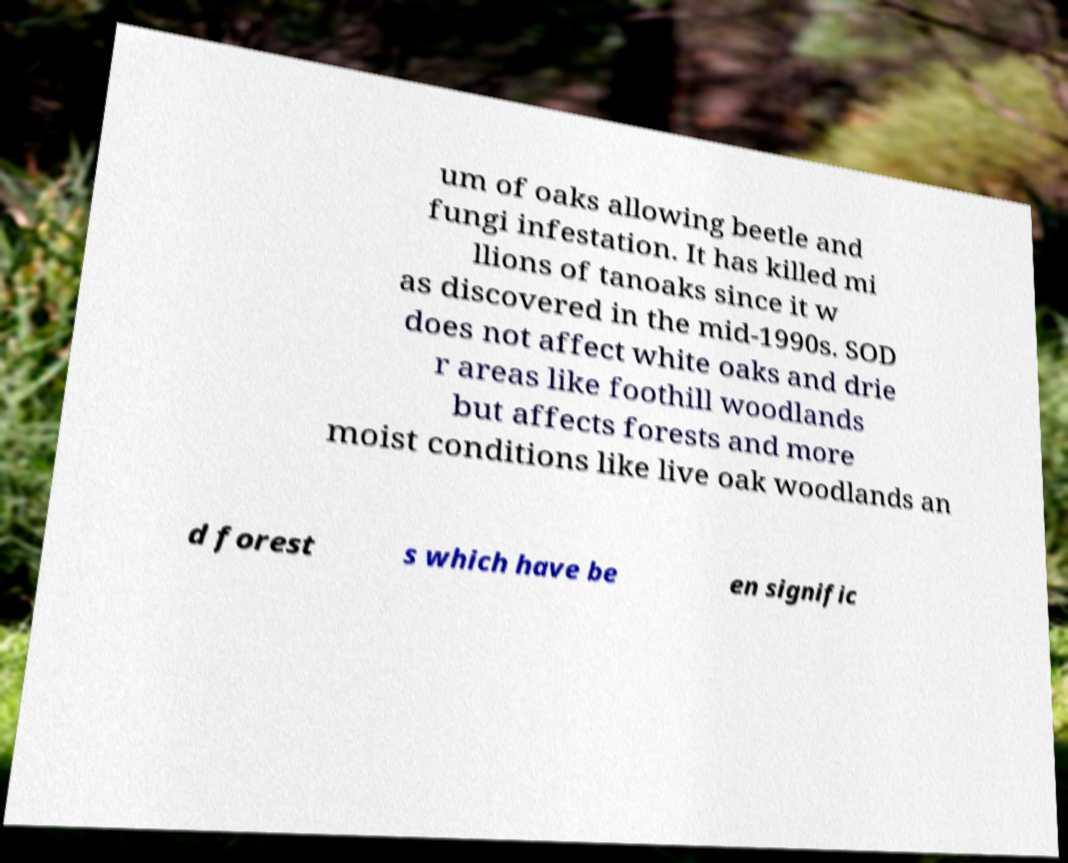What messages or text are displayed in this image? I need them in a readable, typed format. um of oaks allowing beetle and fungi infestation. It has killed mi llions of tanoaks since it w as discovered in the mid-1990s. SOD does not affect white oaks and drie r areas like foothill woodlands but affects forests and more moist conditions like live oak woodlands an d forest s which have be en signific 